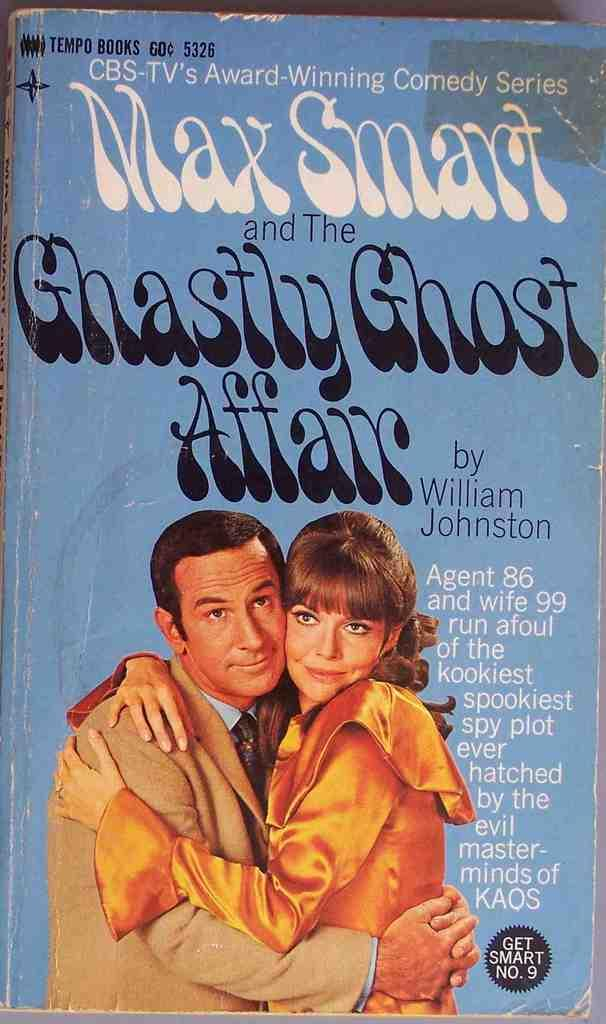<image>
Summarize the visual content of the image. A paperback book brings the Get Smart comedy series to the page. 